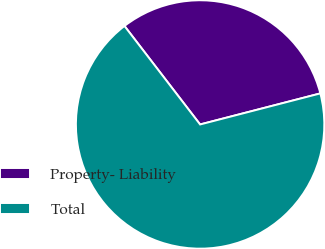<chart> <loc_0><loc_0><loc_500><loc_500><pie_chart><fcel>Property- Liability<fcel>Total<nl><fcel>31.4%<fcel>68.6%<nl></chart> 